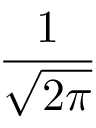<formula> <loc_0><loc_0><loc_500><loc_500>\frac { 1 } { \sqrt { 2 \pi } }</formula> 